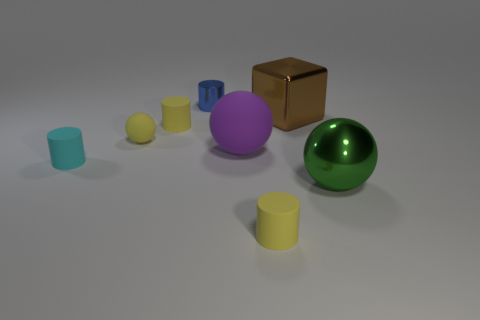Subtract all cyan cylinders. How many cylinders are left? 3 Subtract all cyan cylinders. How many cylinders are left? 3 Subtract 2 spheres. How many spheres are left? 1 Add 1 large brown metallic things. How many objects exist? 9 Subtract all blocks. How many objects are left? 7 Add 3 yellow cylinders. How many yellow cylinders are left? 5 Add 5 rubber spheres. How many rubber spheres exist? 7 Subtract 1 yellow cylinders. How many objects are left? 7 Subtract all purple cubes. Subtract all cyan balls. How many cubes are left? 1 Subtract all green cubes. How many blue cylinders are left? 1 